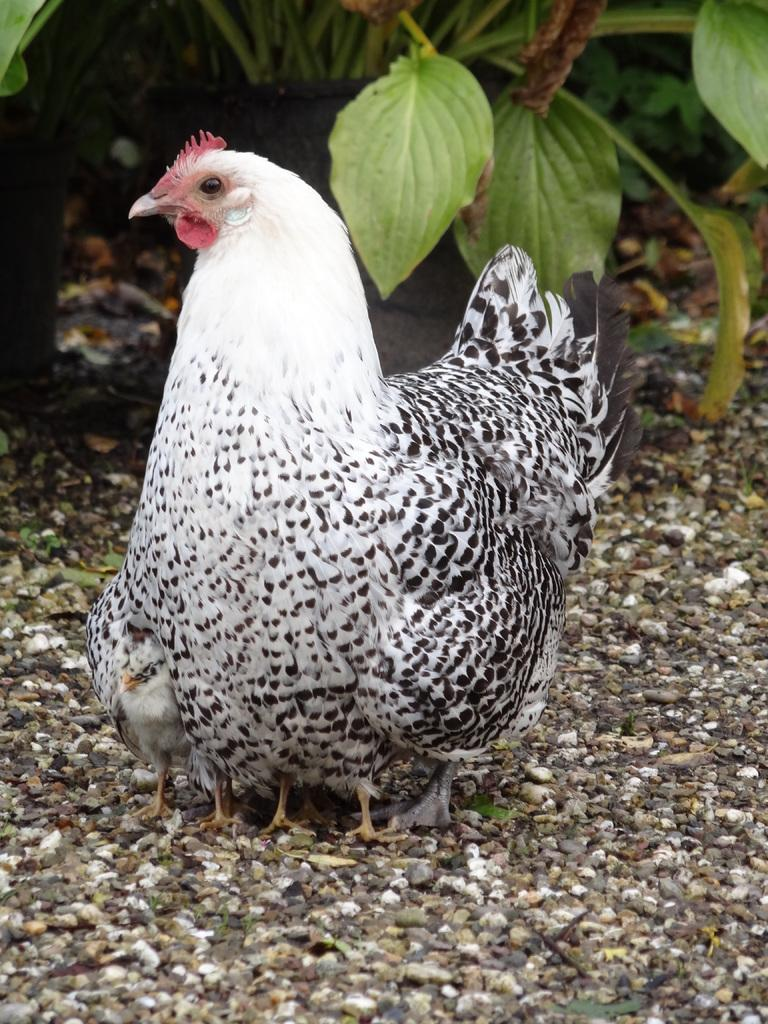What type of animal is in the image? There is a hen in the image. Can you describe the hen's appearance? The hen has white, black, and pink coloring. Are there any other animals in the image? Yes, there are chicks in the image. What can be seen in the background of the image? The background consists of sand and leaves. What is the name of the route the hen is taking in the image? There is no route mentioned in the image, and the hen is not taking any specific path. Can you see any ants in the image? There are no ants present in the image. 